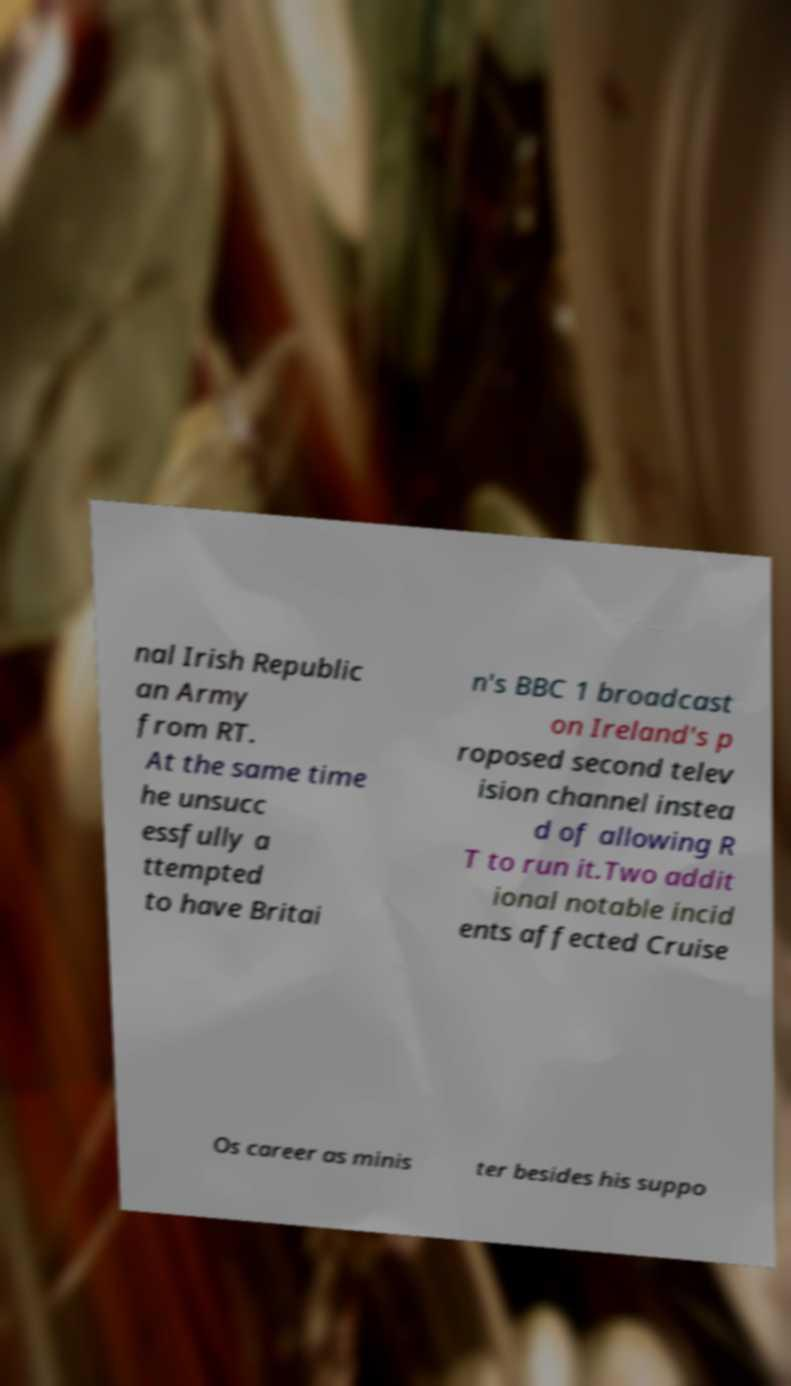There's text embedded in this image that I need extracted. Can you transcribe it verbatim? nal Irish Republic an Army from RT. At the same time he unsucc essfully a ttempted to have Britai n's BBC 1 broadcast on Ireland's p roposed second telev ision channel instea d of allowing R T to run it.Two addit ional notable incid ents affected Cruise Os career as minis ter besides his suppo 